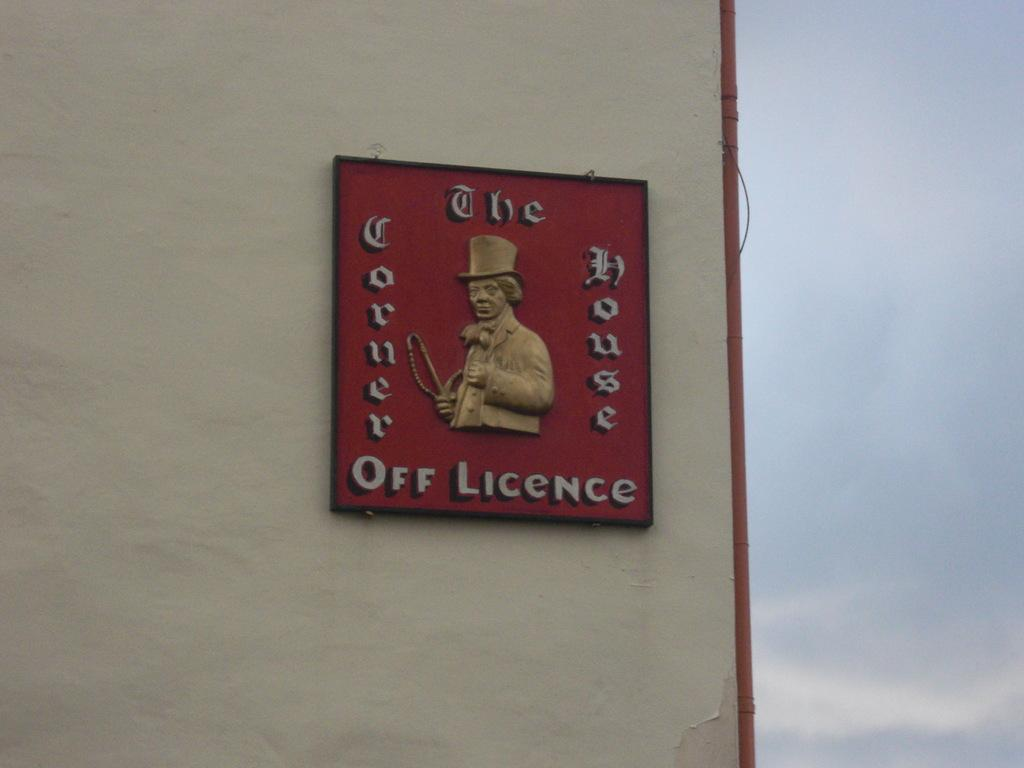<image>
Share a concise interpretation of the image provided. A red sign advertises The Corner House.Off Licence. 